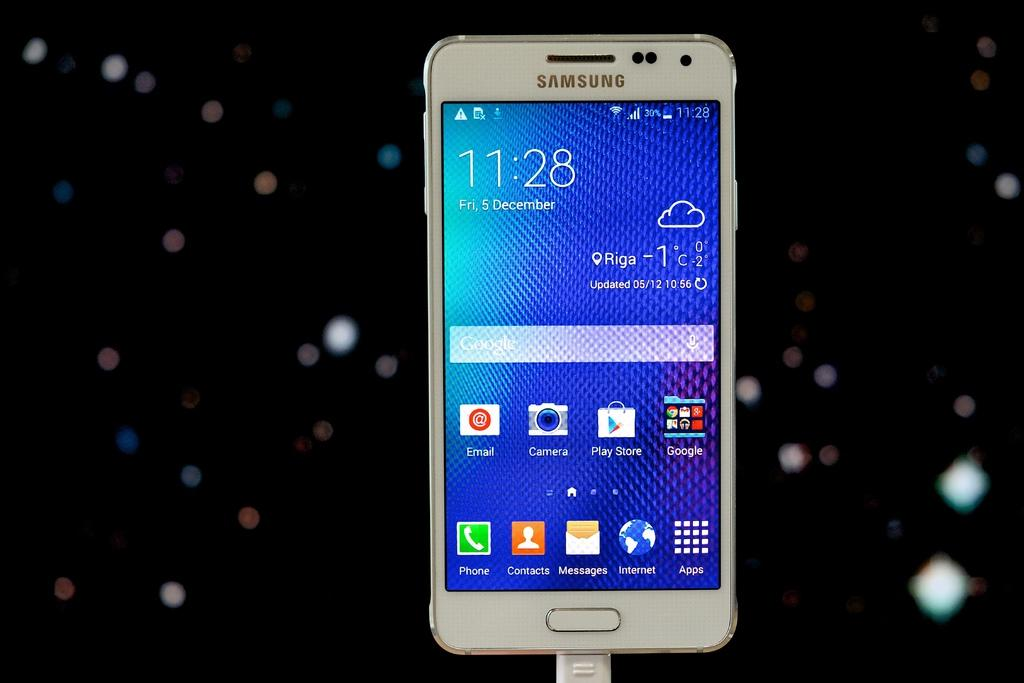<image>
Provide a brief description of the given image. the time on a phone which says 11:28 